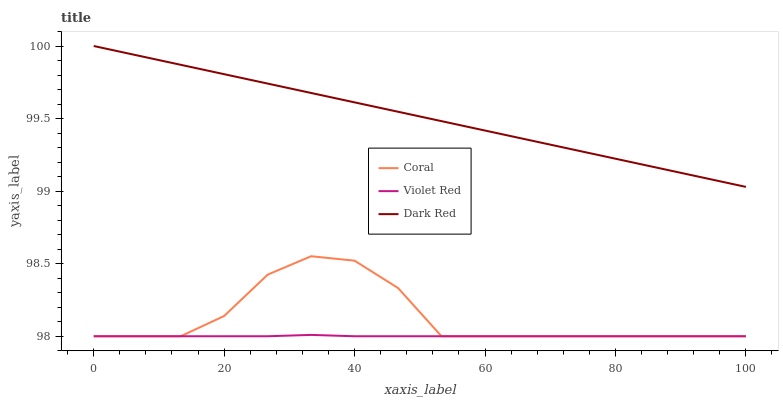Does Coral have the minimum area under the curve?
Answer yes or no. No. Does Coral have the maximum area under the curve?
Answer yes or no. No. Is Violet Red the smoothest?
Answer yes or no. No. Is Violet Red the roughest?
Answer yes or no. No. Does Coral have the highest value?
Answer yes or no. No. Is Coral less than Dark Red?
Answer yes or no. Yes. Is Dark Red greater than Coral?
Answer yes or no. Yes. Does Coral intersect Dark Red?
Answer yes or no. No. 